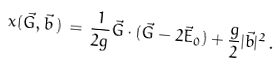<formula> <loc_0><loc_0><loc_500><loc_500>x ( \vec { G } , \vec { b } \, ) \, = \, \frac { 1 } { 2 g } \vec { G } \cdot ( \vec { G } - 2 \vec { E } _ { 0 } ) + \frac { g } { 2 } | \vec { b } | ^ { 2 } \, .</formula> 